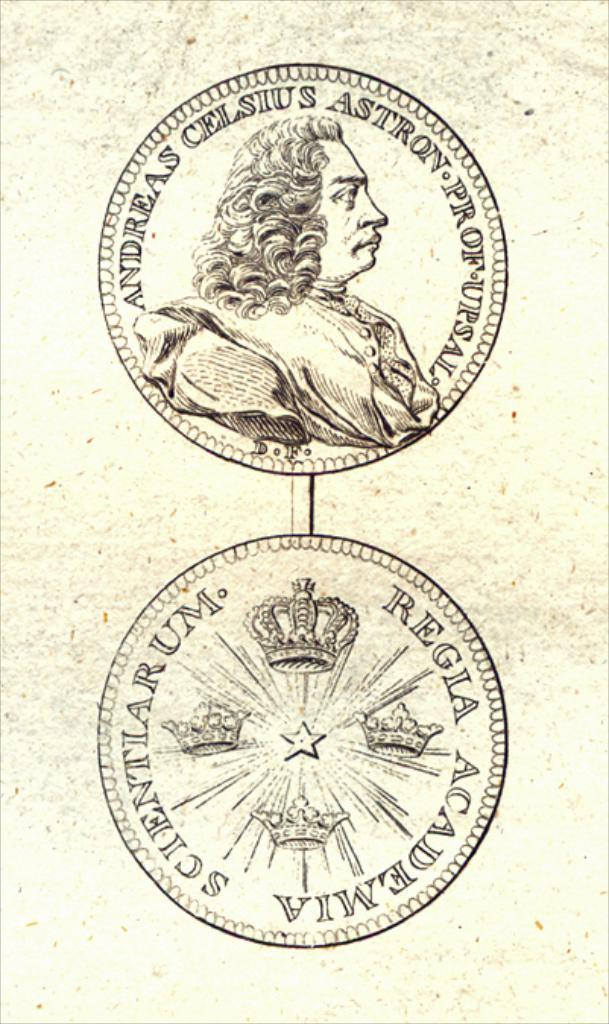How many logos can be seen in the image? There are two logos in the image. What is depicted in the first logo? The first logo has a picture of a person. What else is included in the first logo? The first logo has some writing. What is featured in the second logo? The second logo has crowns. What else is present in the second logo? The second logo has some writing. Can you tell me how many ants are crawling on the knee of the person in the image? There are no ants or knees present in the image; the first logo only features a person's image. What type of cup is being used by the person in the image? There is no cup present in the image; the first logo only features a person's image. 